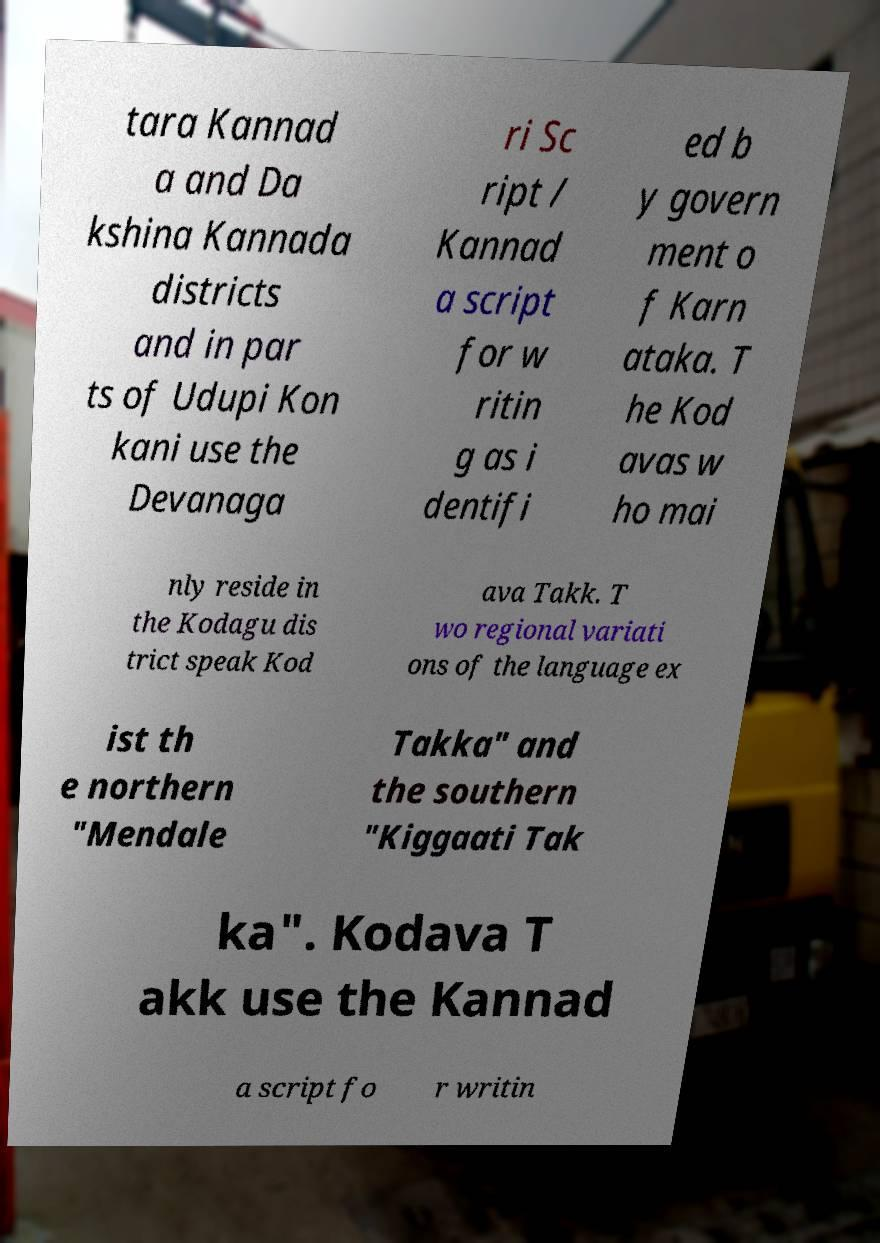Please read and relay the text visible in this image. What does it say? tara Kannad a and Da kshina Kannada districts and in par ts of Udupi Kon kani use the Devanaga ri Sc ript / Kannad a script for w ritin g as i dentifi ed b y govern ment o f Karn ataka. T he Kod avas w ho mai nly reside in the Kodagu dis trict speak Kod ava Takk. T wo regional variati ons of the language ex ist th e northern "Mendale Takka" and the southern "Kiggaati Tak ka". Kodava T akk use the Kannad a script fo r writin 